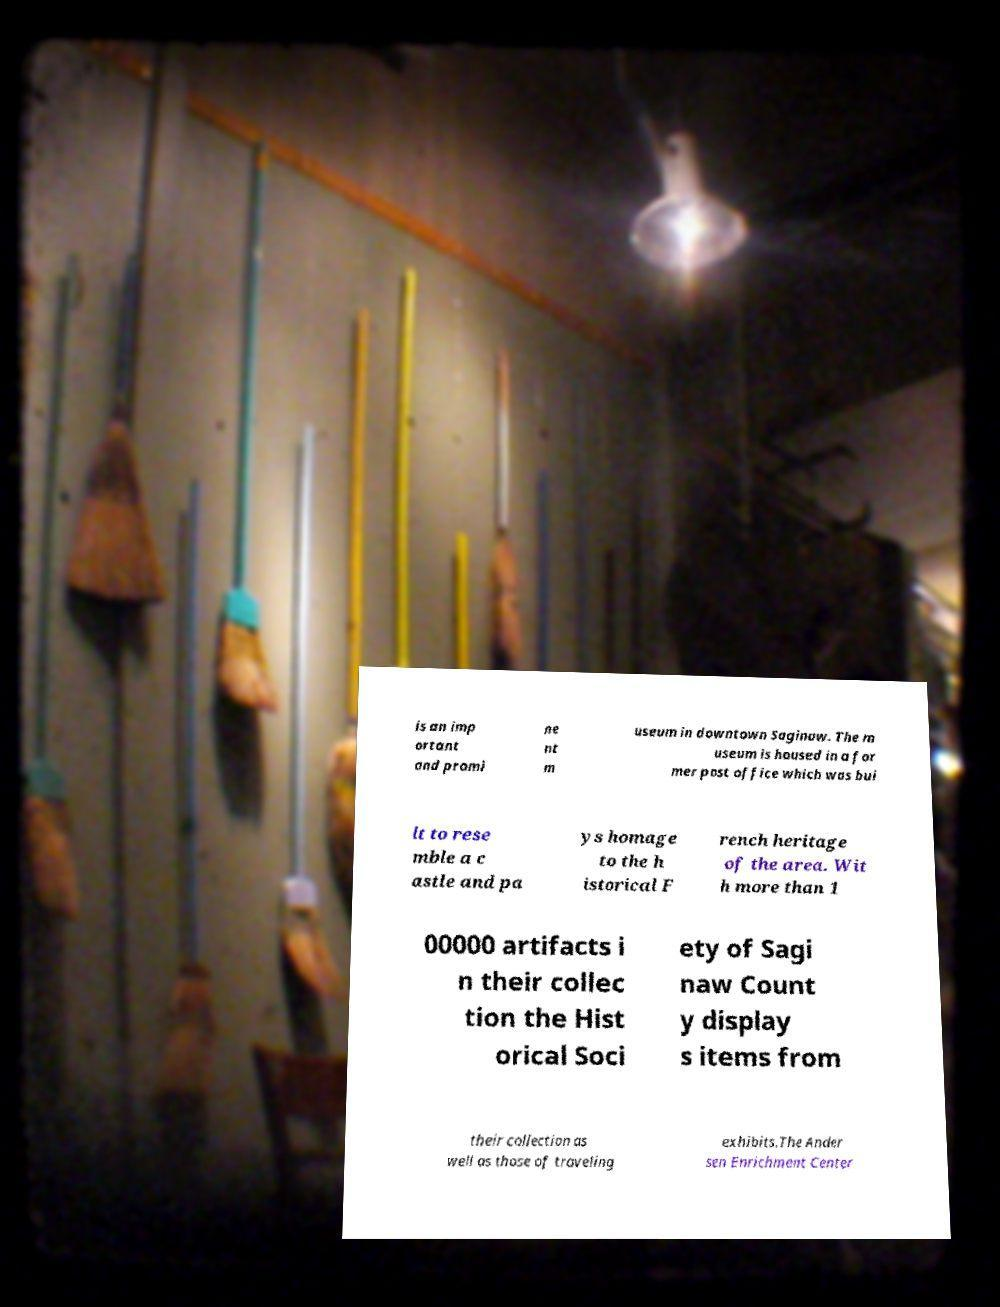There's text embedded in this image that I need extracted. Can you transcribe it verbatim? is an imp ortant and promi ne nt m useum in downtown Saginaw. The m useum is housed in a for mer post office which was bui lt to rese mble a c astle and pa ys homage to the h istorical F rench heritage of the area. Wit h more than 1 00000 artifacts i n their collec tion the Hist orical Soci ety of Sagi naw Count y display s items from their collection as well as those of traveling exhibits.The Ander sen Enrichment Center 